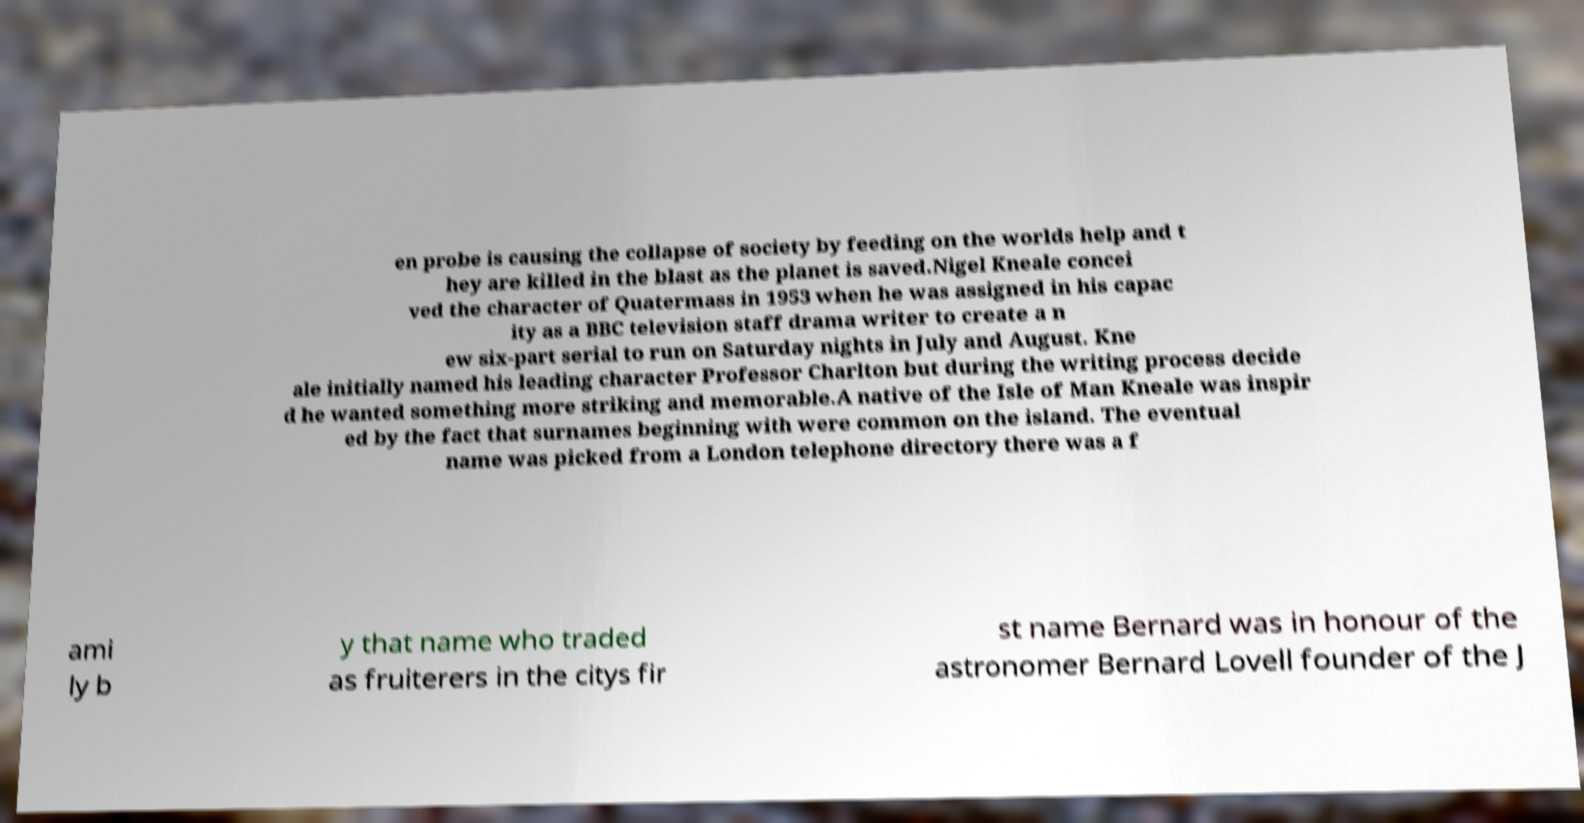There's text embedded in this image that I need extracted. Can you transcribe it verbatim? en probe is causing the collapse of society by feeding on the worlds help and t hey are killed in the blast as the planet is saved.Nigel Kneale concei ved the character of Quatermass in 1953 when he was assigned in his capac ity as a BBC television staff drama writer to create a n ew six-part serial to run on Saturday nights in July and August. Kne ale initially named his leading character Professor Charlton but during the writing process decide d he wanted something more striking and memorable.A native of the Isle of Man Kneale was inspir ed by the fact that surnames beginning with were common on the island. The eventual name was picked from a London telephone directory there was a f ami ly b y that name who traded as fruiterers in the citys fir st name Bernard was in honour of the astronomer Bernard Lovell founder of the J 